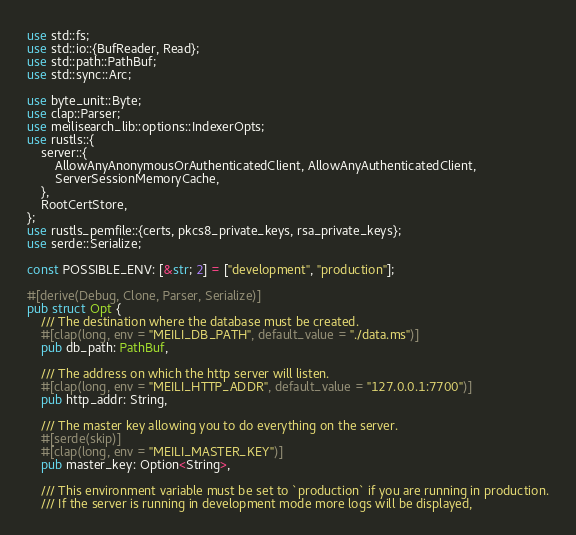<code> <loc_0><loc_0><loc_500><loc_500><_Rust_>use std::fs;
use std::io::{BufReader, Read};
use std::path::PathBuf;
use std::sync::Arc;

use byte_unit::Byte;
use clap::Parser;
use meilisearch_lib::options::IndexerOpts;
use rustls::{
    server::{
        AllowAnyAnonymousOrAuthenticatedClient, AllowAnyAuthenticatedClient,
        ServerSessionMemoryCache,
    },
    RootCertStore,
};
use rustls_pemfile::{certs, pkcs8_private_keys, rsa_private_keys};
use serde::Serialize;

const POSSIBLE_ENV: [&str; 2] = ["development", "production"];

#[derive(Debug, Clone, Parser, Serialize)]
pub struct Opt {
    /// The destination where the database must be created.
    #[clap(long, env = "MEILI_DB_PATH", default_value = "./data.ms")]
    pub db_path: PathBuf,

    /// The address on which the http server will listen.
    #[clap(long, env = "MEILI_HTTP_ADDR", default_value = "127.0.0.1:7700")]
    pub http_addr: String,

    /// The master key allowing you to do everything on the server.
    #[serde(skip)]
    #[clap(long, env = "MEILI_MASTER_KEY")]
    pub master_key: Option<String>,

    /// This environment variable must be set to `production` if you are running in production.
    /// If the server is running in development mode more logs will be displayed,</code> 